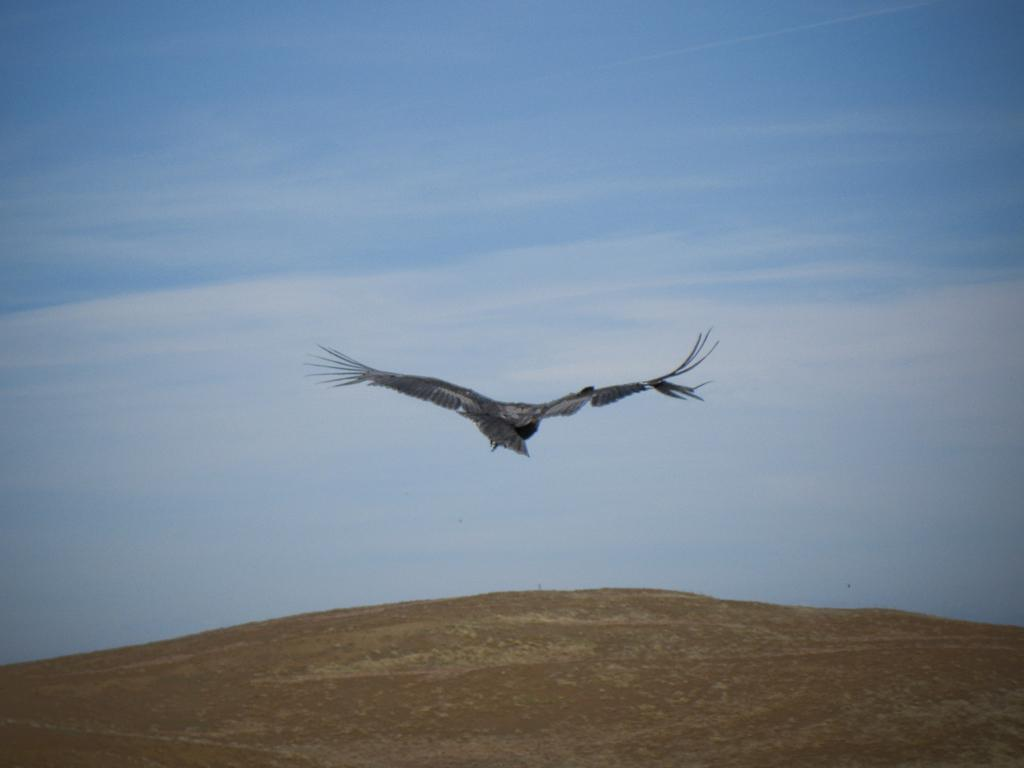What type of animal can be seen in the image? There is a bird in the image. What is the bird doing in the image? The bird is flying in the sky. What else can be seen in the image besides the bird? There is land visible in the image. What type of sign can be seen on the roof in the image? There is no roof or sign present in the image; it features a bird flying in the sky and land below. 